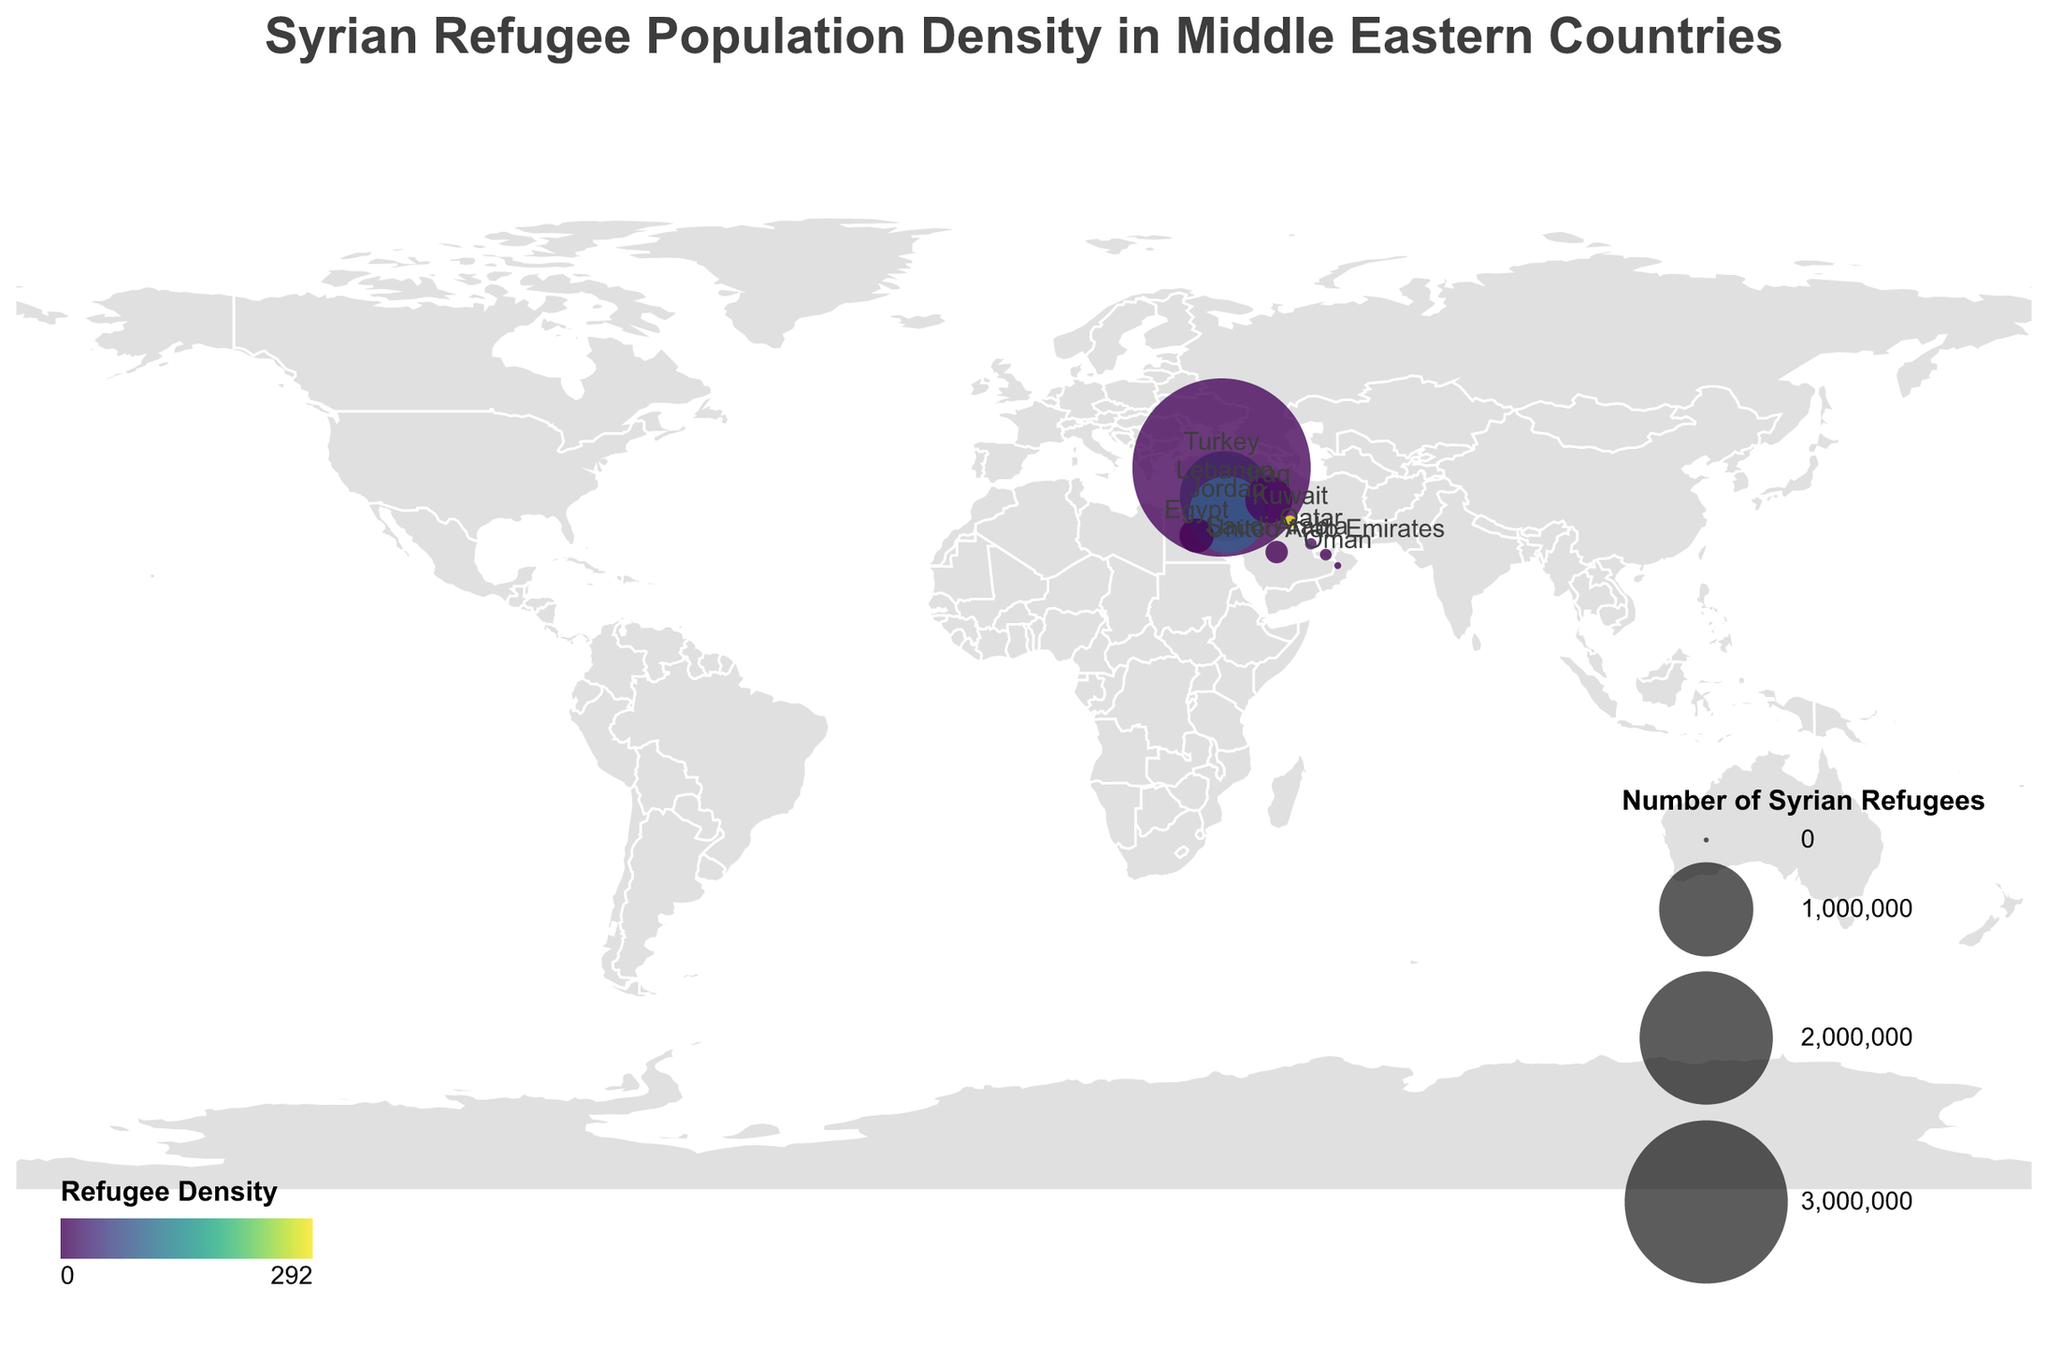What is the title of the figure? The title is displayed at the top of the figure. It reads "Syrian Refugee Population Density in Middle Eastern Countries".
Answer: Syrian Refugee Population Density in Middle Eastern Countries Which country hosts the largest number of Syrian refugees? By looking at the size of the circles, the largest circle represents Turkey, indicating it hosts the largest number of Syrian refugees. The tooltip confirms that Turkey has 3,585,738 Syrian refugees.
Answer: Turkey What is the refugee density in Lebanon compared to Jordan? The color of the circles represents refugee density. Lebanon's circle is darker than Jordan's, indicating a higher refugee density. Lebanon's refugee density is 143.2, while Jordan's is 83.4.
Answer: Lebanon has a higher refugee density than Jordan How does the number of Syrian refugees in Egypt compare to that in Iraq? Checking the size of the circles for both Egypt and Iraq, Iraq's circle is larger than Egypt's. The exact numbers show Iraq has 247,305 Syrian refugees, whereas Egypt has 130,074.
Answer: Iraq has more Syrian refugees than Egypt Which country has the highest refugee density and what is its value? The color scale and the tooltips indicate that Kuwait has the highest refugee density with a value of 292.1.
Answer: Kuwait, 292.1 How many Syrian refugees are there in total across all the listed countries? Summing the 'Syrian_Refugees' values for all countries: 916,113 (Lebanon) + 3,585,738 (Turkey) + 660,393 (Jordan) + 247,305 (Iraq) + 130,074 (Egypt) + 54,069 (Saudi Arabia) + 14,312 (Kuwait) + 12,601 (United Arab Emirates) + 11,957 (Qatar) + 2,680 (Oman) = 5,635,242.
Answer: 5,635,242 Which three countries have the lowest refugee densities, and what are their values? The lightest-colored circles represent the lowest refugee densities. These countries are Oman with 0.1, Saudi Arabia with 0.03, and Egypt with 0.3.
Answer: Oman, Saudi Arabia, and Egypt; 0.1, 0.03, and 0.3 respectively What is the average refugee density across all listed countries? Adding the refugee densities for all countries: 143.2 (Lebanon) + 5.0 (Turkey) + 83.4 (Jordan) + 6.3 (Iraq) + 0.3 (Egypt) + 0.03 (Saudi Arabia) + 292.1 (Kuwait) + 1.8 (United Arab Emirates) + 11.7 (Qatar) + 0.1 (Oman) = 544.93. Dividing by the number of countries (10) gives an average of 54.49.
Answer: 54.49 